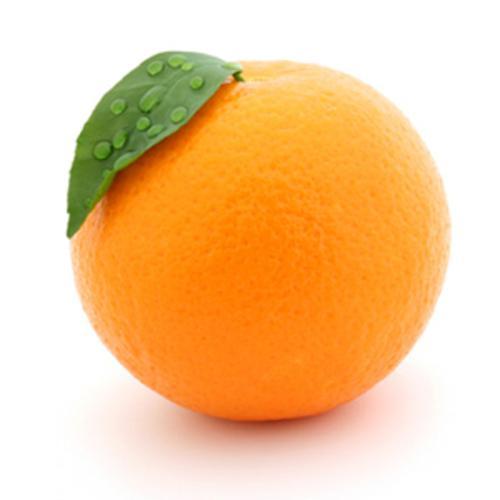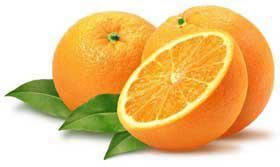The first image is the image on the left, the second image is the image on the right. Evaluate the accuracy of this statement regarding the images: "The left image contains only a half orange next to a whole orange, and the right image includes a half orange, orange wedge, whole orange, and green leaves.". Is it true? Answer yes or no. No. 